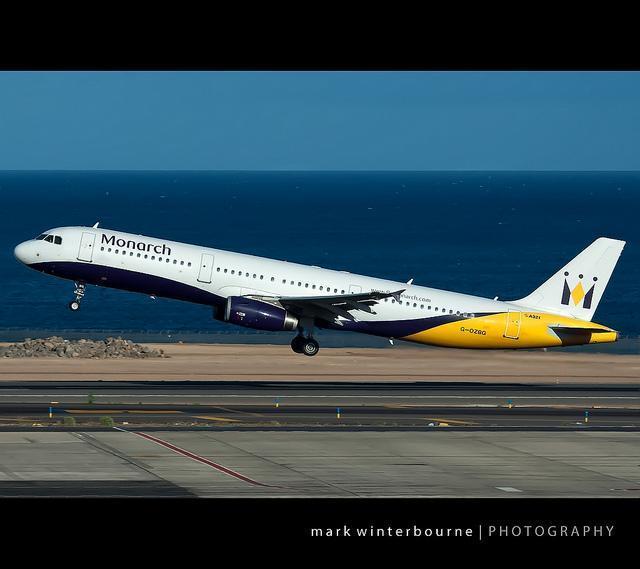How many yellow doors are there?
Give a very brief answer. 1. How many people are wearing brown shirts?
Give a very brief answer. 0. 